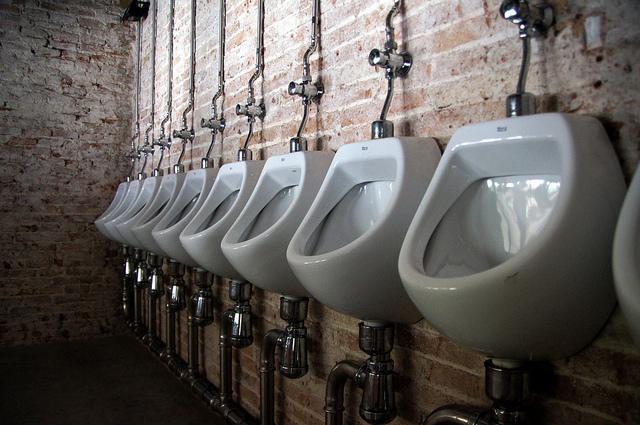How many urinals are there?
Give a very brief answer. 10. How many toilets are in the photo?
Give a very brief answer. 4. 